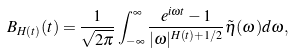Convert formula to latex. <formula><loc_0><loc_0><loc_500><loc_500>B _ { H ( t ) } ( t ) = \frac { 1 } { \sqrt { 2 \pi } } \int _ { - \infty } ^ { \infty } \frac { e ^ { i \omega t } - 1 } { | \omega | ^ { H ( t ) + 1 / 2 } } \tilde { \eta } ( \omega ) d \omega ,</formula> 